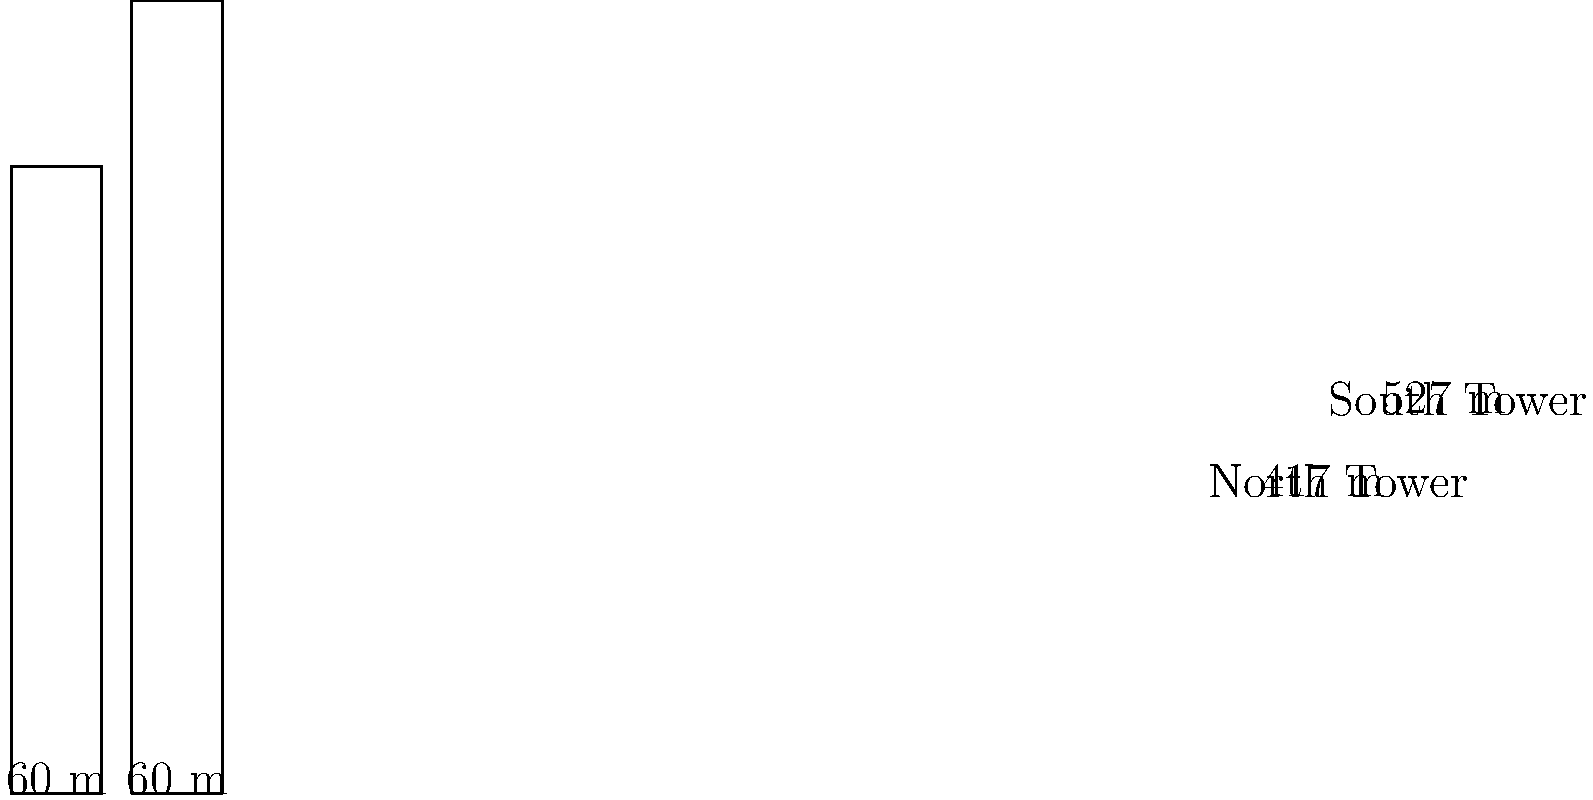The Twin Towers, iconic symbols of New York City, had distinct geometric proportions. The North Tower stood at 417 meters tall with a base width of 60 meters, while the South Tower was 527 meters tall with the same base width. What was the ratio of the height to the base width for the South Tower, rounded to the nearest hundredth? To find the ratio of height to base width for the South Tower, we need to follow these steps:

1) Identify the height and base width of the South Tower:
   Height = 527 meters
   Base width = 60 meters

2) Set up the ratio of height to base width:
   Ratio = Height ÷ Base width
   
3) Perform the division:
   Ratio = 527 ÷ 60 = 8.7833333...

4) Round the result to the nearest hundredth:
   8.7833333... rounds to 8.78

Therefore, the ratio of height to base width for the South Tower is 8.78 to 1.
Answer: 8.78:1 